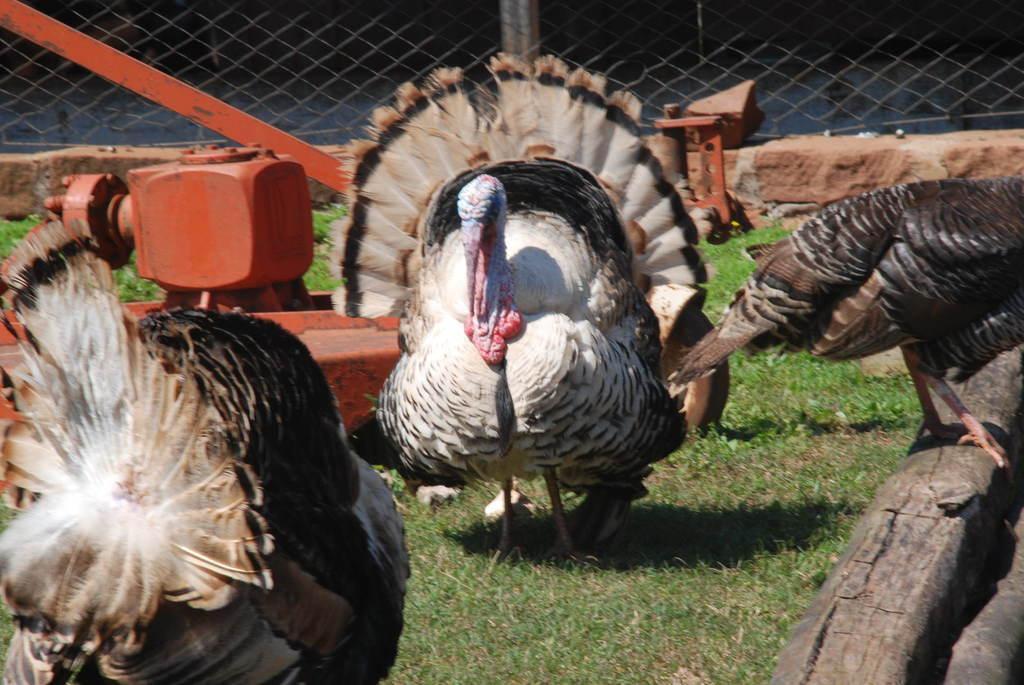Please provide a concise description of this image. In this image we can see the turkeys. We can also see the orange color machine, grass, bark and also the fence in the background. 